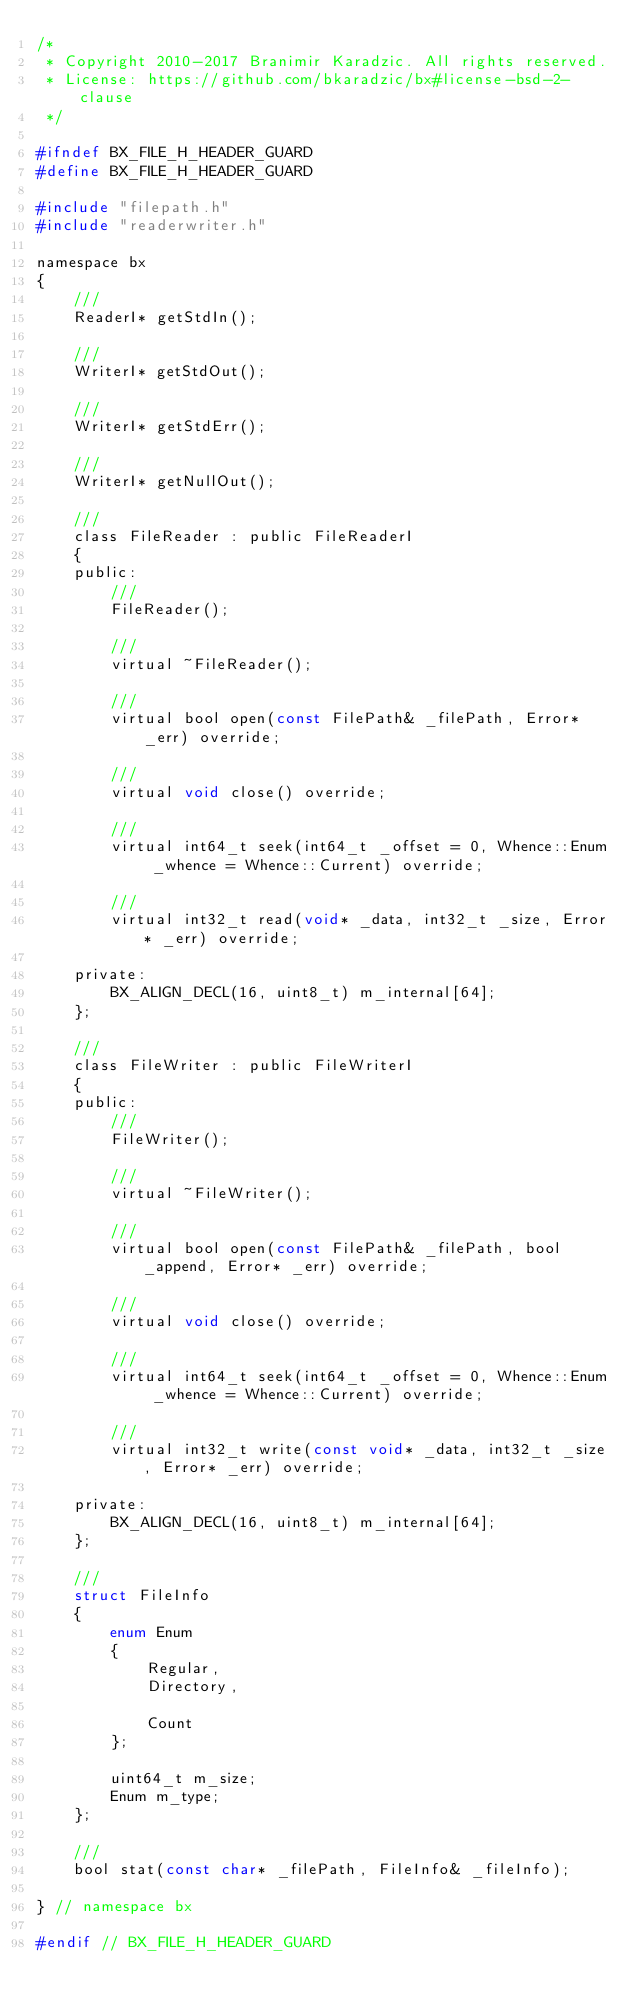<code> <loc_0><loc_0><loc_500><loc_500><_C_>/*
 * Copyright 2010-2017 Branimir Karadzic. All rights reserved.
 * License: https://github.com/bkaradzic/bx#license-bsd-2-clause
 */

#ifndef BX_FILE_H_HEADER_GUARD
#define BX_FILE_H_HEADER_GUARD

#include "filepath.h"
#include "readerwriter.h"

namespace bx
{
	///
	ReaderI* getStdIn();

	///
	WriterI* getStdOut();

	///
	WriterI* getStdErr();

	///
	WriterI* getNullOut();

	///
	class FileReader : public FileReaderI
	{
	public:
		///
		FileReader();

		///
		virtual ~FileReader();

		///
		virtual bool open(const FilePath& _filePath, Error* _err) override;

		///
		virtual void close() override;

		///
		virtual int64_t seek(int64_t _offset = 0, Whence::Enum _whence = Whence::Current) override;

		///
		virtual int32_t read(void* _data, int32_t _size, Error* _err) override;

	private:
		BX_ALIGN_DECL(16, uint8_t) m_internal[64];
	};

	///
	class FileWriter : public FileWriterI
	{
	public:
		///
		FileWriter();

		///
		virtual ~FileWriter();

		///
		virtual bool open(const FilePath& _filePath, bool _append, Error* _err) override;

		///
		virtual void close() override;

		///
		virtual int64_t seek(int64_t _offset = 0, Whence::Enum _whence = Whence::Current) override;

		///
		virtual int32_t write(const void* _data, int32_t _size, Error* _err) override;

	private:
		BX_ALIGN_DECL(16, uint8_t) m_internal[64];
	};

	///
	struct FileInfo
	{
		enum Enum
		{
			Regular,
			Directory,

			Count
		};

		uint64_t m_size;
		Enum m_type;
	};

	///
	bool stat(const char* _filePath, FileInfo& _fileInfo);

} // namespace bx

#endif // BX_FILE_H_HEADER_GUARD
</code> 